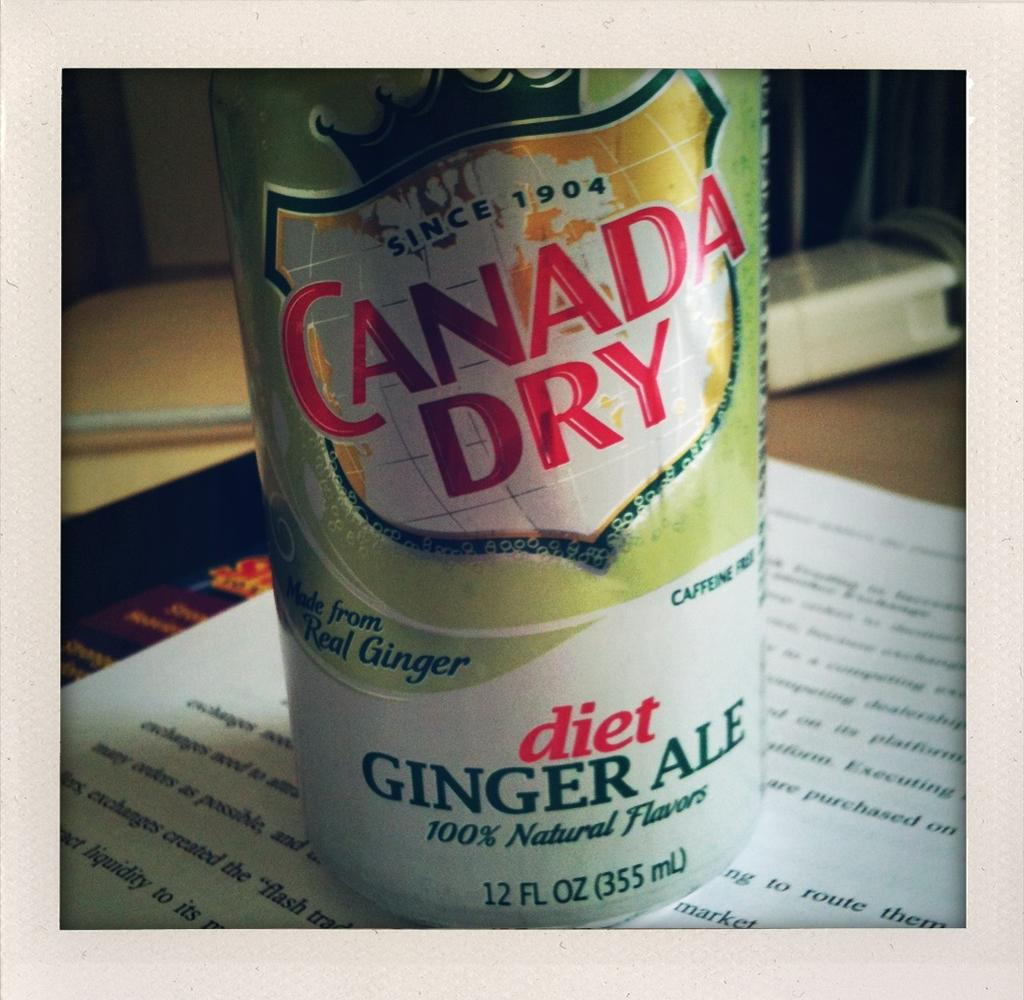<image>
Present a compact description of the photo's key features. A can of diet ginger ale is sitting on an object with words 